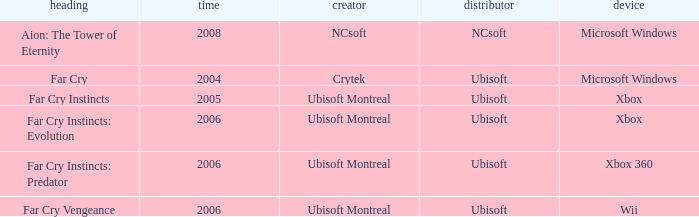Which publisher has Far Cry as the title? Ubisoft. 